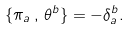Convert formula to latex. <formula><loc_0><loc_0><loc_500><loc_500>\{ \pi _ { a } \, , \, \theta ^ { b } \} = - \delta ^ { b } _ { a } .</formula> 